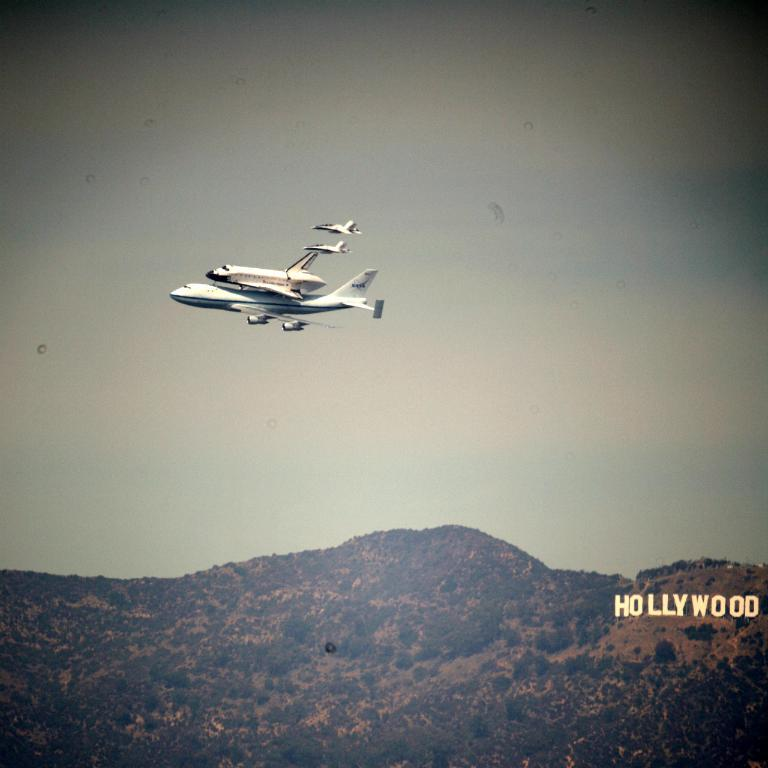<image>
Share a concise interpretation of the image provided. Planes are soaring over the Hollywood hills during the day. 